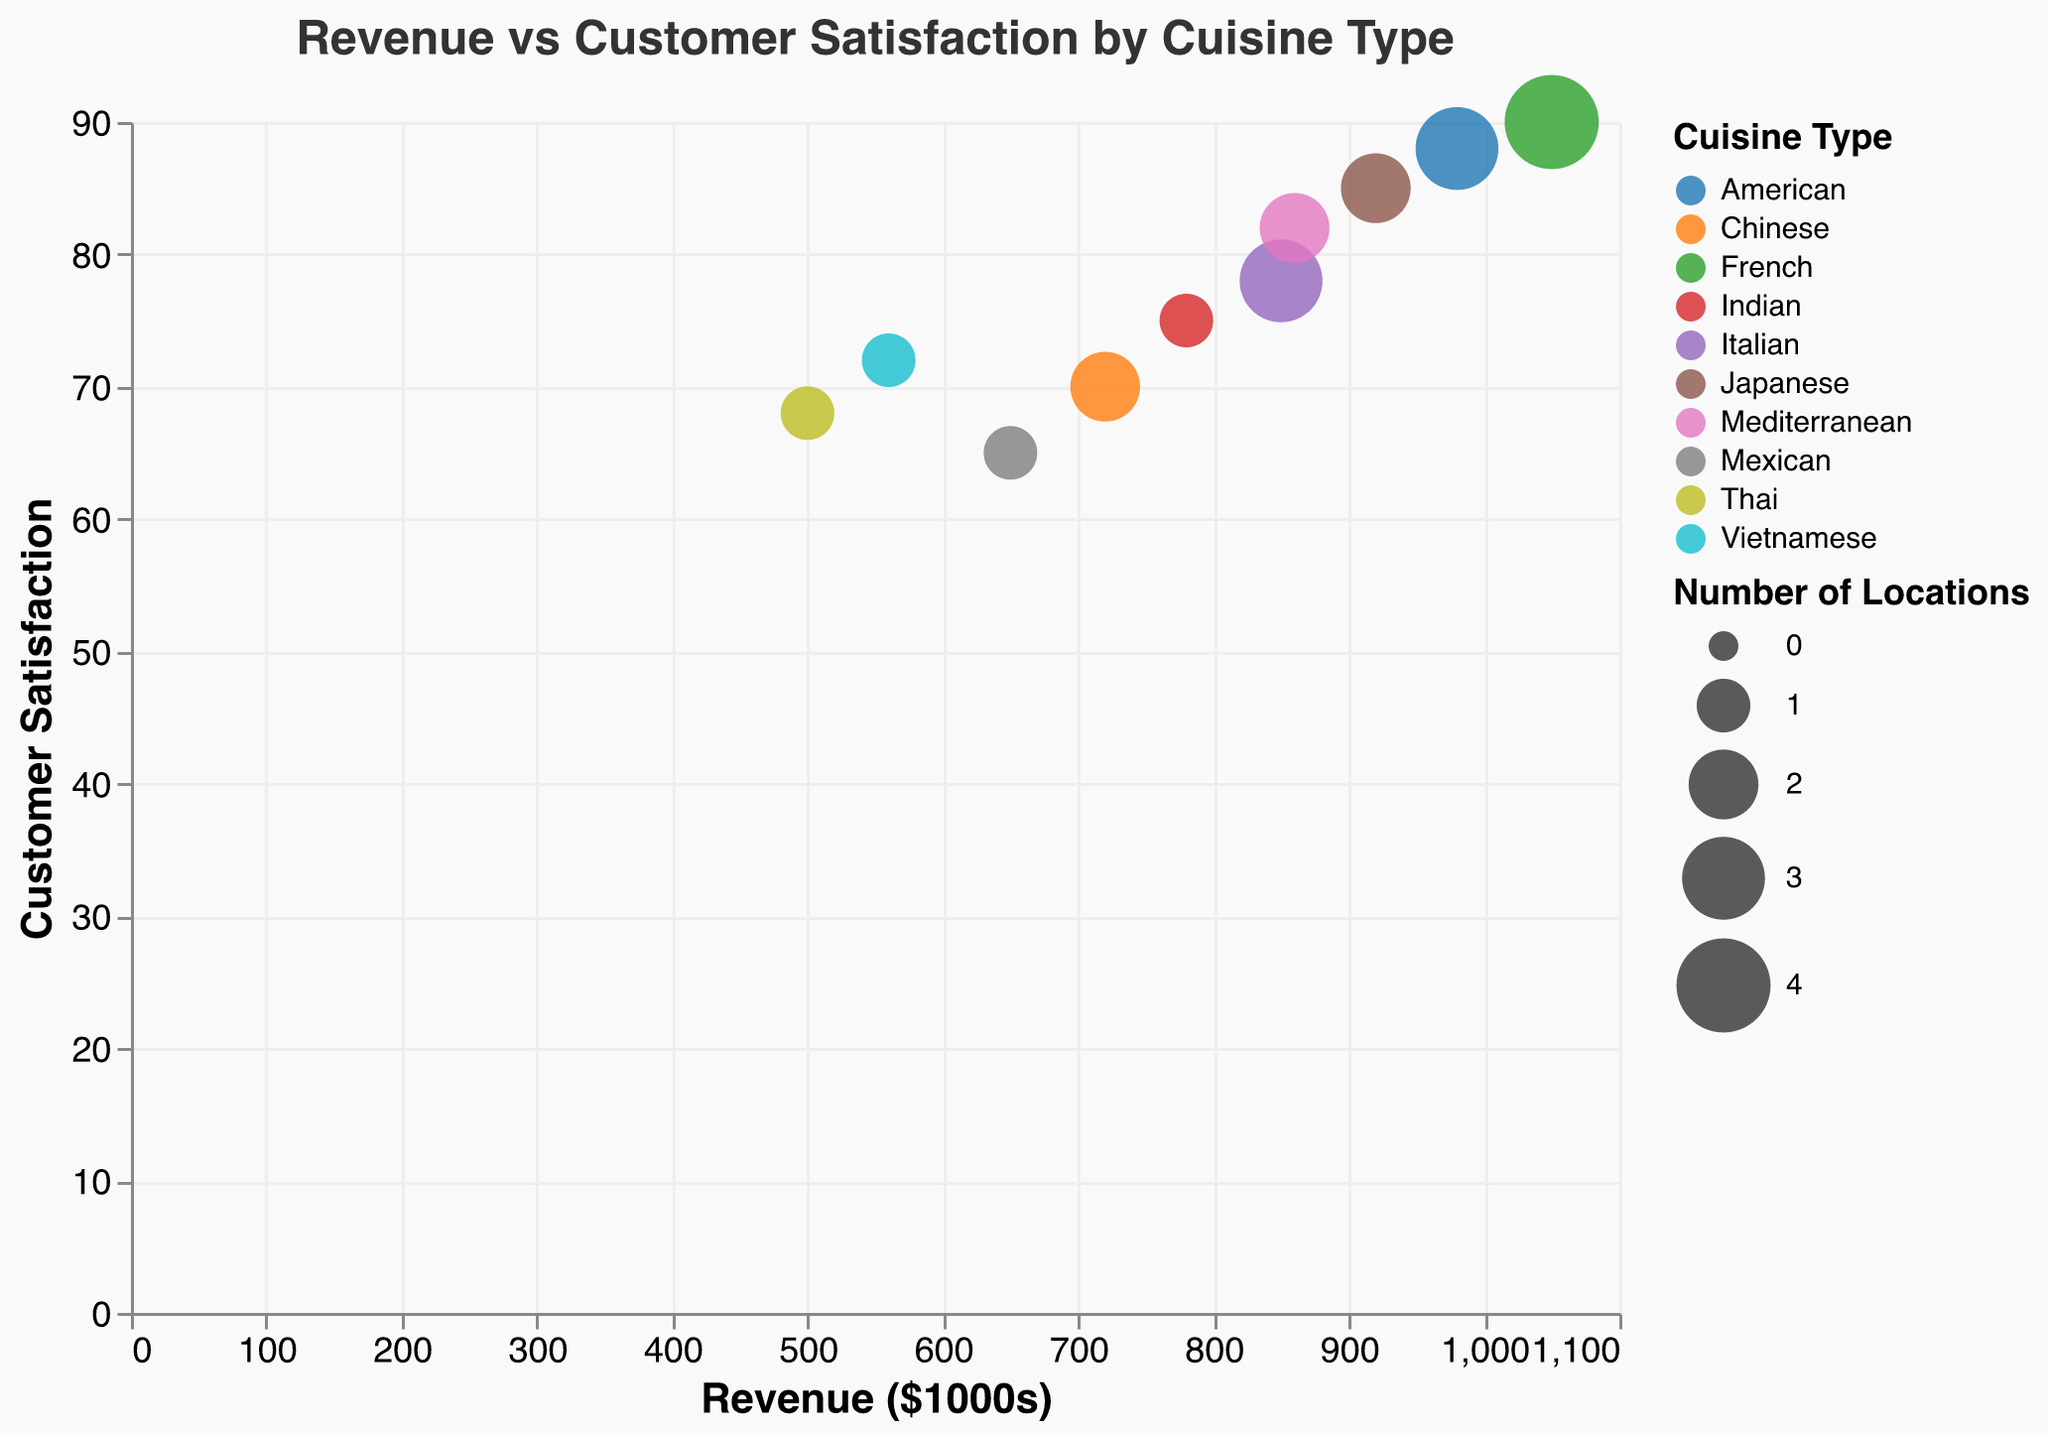How many cuisine types are represented in the chart? Count the distinct color groups representing different cuisine types. There are 10 different colors for 10 cuisine types.
Answer: 10 Which restaurant has the highest customer satisfaction? Identify the data point with the highest y-axis value, which is 90 for Le Bistro.
Answer: Le Bistro Which cuisine type has the highest revenue? Locate the data point with the highest x-axis value to find 1050, representing French cuisine (Le Bistro).
Answer: French What is the difference in revenue between Liberty Grill and Pho Haven? Calculate the difference between 980 (Liberty Grill) and 560 (Pho Haven). The result is 420.
Answer: 420 Which cuisine type has the least number of locations? Identify data points with the smallest bubble size (1 location), which are Mexican, Indian, Thai, and Vietnamese cuisines.
Answer: Mexican, Indian, Thai, Vietnamese What is the average customer satisfaction for restaurants with 2 locations? Locate data points with 2 locations, which are Sakura Sushi, Golden Dragon, and Olive Branch. Their customer satisfaction values are 85, 70, and 82. The average is (85 + 70 + 82) / 3 = 79.
Answer: 79 Which restaurant, on average, has higher customer satisfaction: those with 1 location or those with 3 locations? For 1 location: El Rancho, Curry House, Spice Garden, Pho Haven with values (65 + 75 + 68 + 72)/4 = 70. For 3 locations: Luigi's Trattoria, Liberty Grill with values (78 + 88)/2 = 83. Thus, restaurants with 3 locations have higher average customer satisfaction.
Answer: 3 locations Is there a positive correlation between revenue and customer satisfaction? Observe the overall trend of the data points. As revenue increases, customer satisfaction generally increases, indicating a positive correlation.
Answer: Yes Which restaurant with more than 2 locations has the highest revenue? Identify restaurants with more than 2 locations: Luigi’s Trattoria, Le Bistro, and Liberty Grill. Among these, Le Bistro has the highest revenue of 1050.
Answer: Le Bistro 